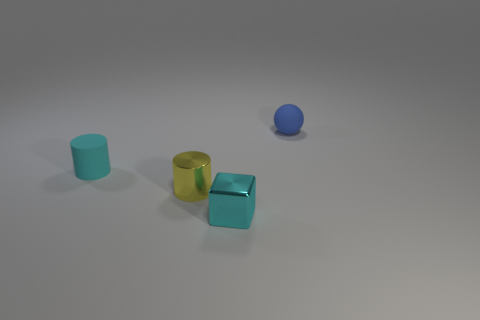There is a cyan matte object that is the same shape as the small yellow object; what is its size?
Offer a terse response. Small. There is a tiny cyan thing that is behind the yellow metal cylinder; what is it made of?
Provide a short and direct response. Rubber. What number of small things are cyan rubber things or green balls?
Keep it short and to the point. 1. There is a cylinder right of the cyan cylinder; is it the same size as the matte sphere?
Keep it short and to the point. Yes. How many other things are the same color as the small matte sphere?
Offer a terse response. 0. What is the material of the ball?
Provide a short and direct response. Rubber. There is a thing that is both behind the tiny shiny cylinder and to the right of the cyan matte cylinder; what is its material?
Ensure brevity in your answer.  Rubber. What number of objects are tiny cyan objects that are in front of the yellow metallic cylinder or large brown spheres?
Offer a very short reply. 1. Do the matte cylinder and the ball have the same color?
Ensure brevity in your answer.  No. Is there a brown sphere of the same size as the blue matte thing?
Provide a succinct answer. No. 